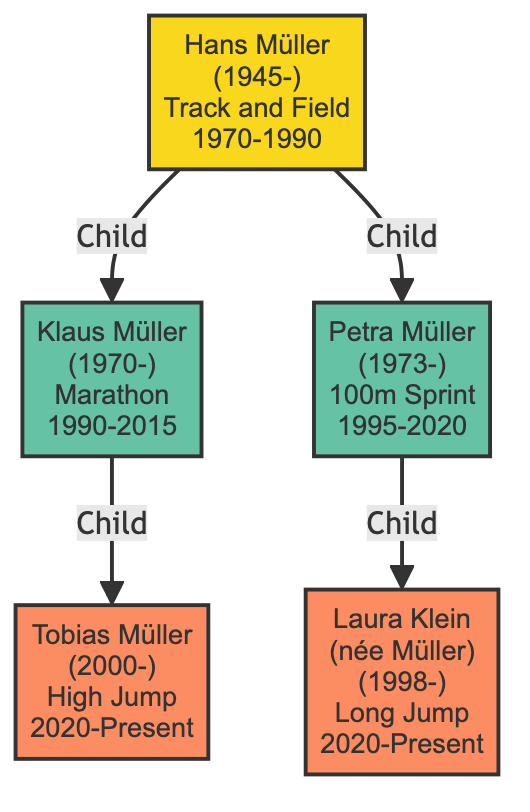What is the birth year of Hans Müller? The birth year of Hans Müller is listed in the diagram as 1945.
Answer: 1945 How many children does Hans Müller have? The diagram shows two children: Klaus Müller and Petra Müller. Therefore, Hans Müller has two children.
Answer: 2 Which specialty is associated with Tobias Müller? The specialty noted for Tobias Müller in the diagram is High Jump.
Answer: High Jump What years did Klaus Müller actively commentate? The activity period for Klaus Müller stated in the diagram spans from 1990 to 2015.
Answer: 1990-2015 Who are the grandchildren of Hans Müller? According to the diagram, Hans Müller has two grandchildren: Tobias Müller and Laura Klein (née Müller).
Answer: Tobias Müller, Laura Klein (née Müller) What is the relationship between Klaus Müller and Tobias Müller? Klaus Müller is listed as the parent of Tobias Müller in the diagram, indicating that Tobias Müller is Klaus Müller’s child.
Answer: Parent-Child In what year did Petra Müller start her commentary period? The diagram indicates that Petra Müller began her commentary activity in 1995.
Answer: 1995 How many generations of commentators are depicted in the diagram? The diagram depicts three generations: Hans Müller (the first generation), his children Klaus and Petra Müller (the second generation), and their children Tobias and Laura Klein (the third generation).
Answer: 3 What is the specialty of Laura Klein? The diagram states that Laura Klein (née Müller) specializes in Long Jump.
Answer: Long Jump 